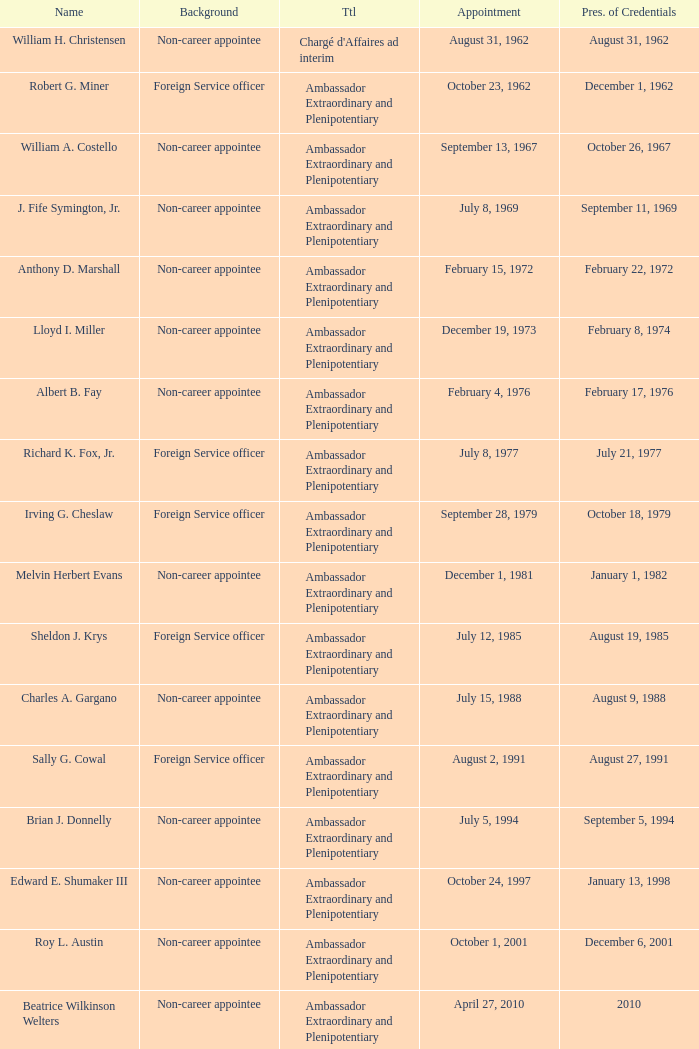When did Robert G. Miner present his credentials? December 1, 1962. 